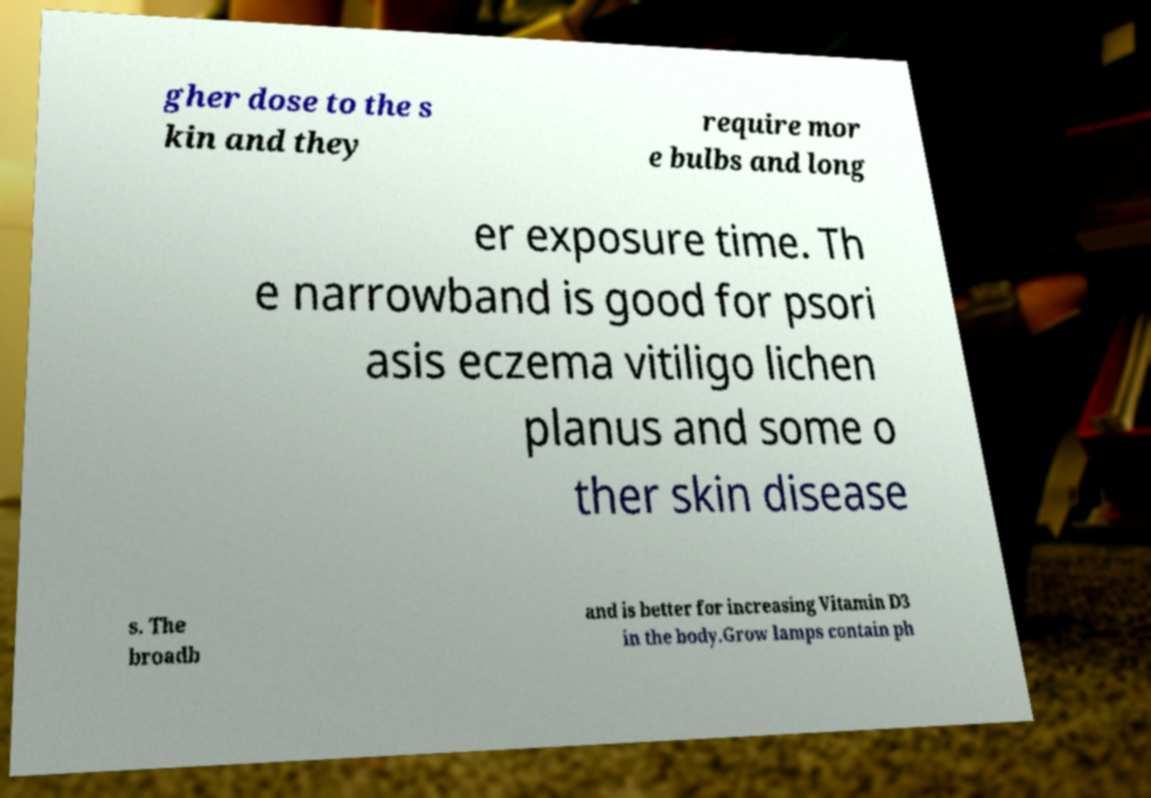I need the written content from this picture converted into text. Can you do that? gher dose to the s kin and they require mor e bulbs and long er exposure time. Th e narrowband is good for psori asis eczema vitiligo lichen planus and some o ther skin disease s. The broadb and is better for increasing Vitamin D3 in the body.Grow lamps contain ph 